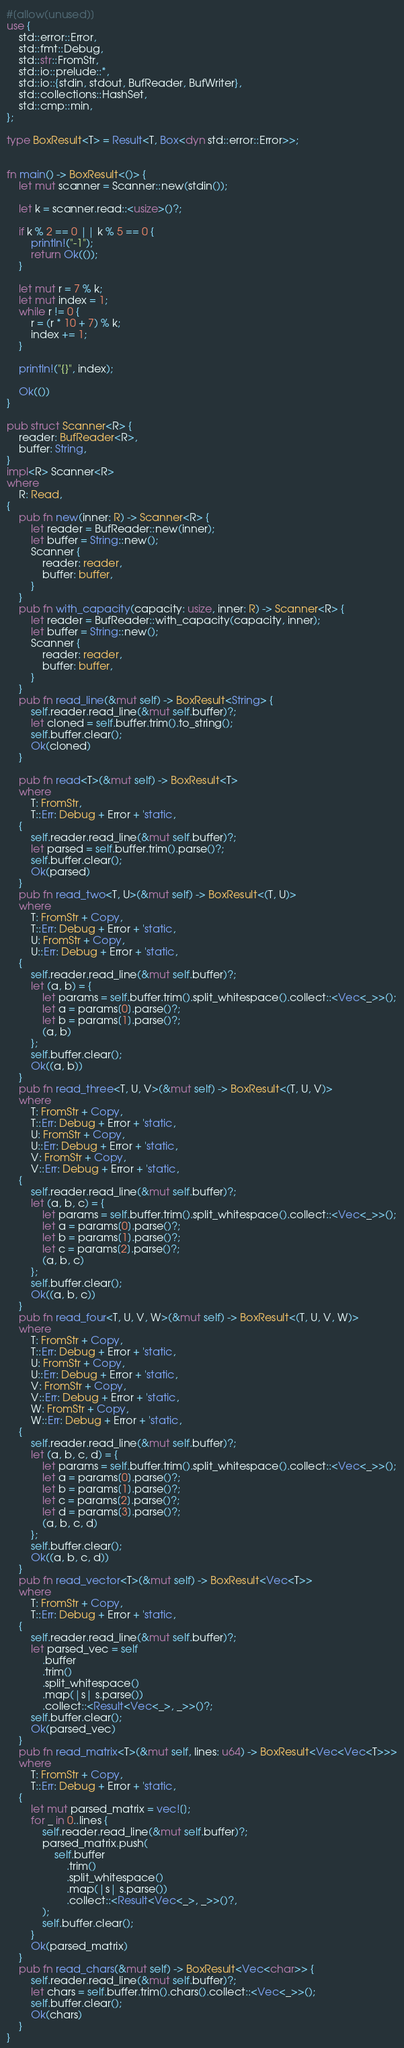Convert code to text. <code><loc_0><loc_0><loc_500><loc_500><_Rust_>#[allow(unused)]
use {
    std::error::Error,
    std::fmt::Debug,
    std::str::FromStr,
    std::io::prelude::*,
    std::io::{stdin, stdout, BufReader, BufWriter},
    std::collections::HashSet,
    std::cmp::min,
};

type BoxResult<T> = Result<T, Box<dyn std::error::Error>>;


fn main() -> BoxResult<()> {
    let mut scanner = Scanner::new(stdin());
    
    let k = scanner.read::<usize>()?;

    if k % 2 == 0 || k % 5 == 0 {
        println!("-1");
        return Ok(());
    }

    let mut r = 7 % k;
    let mut index = 1;
    while r != 0 {
        r = (r * 10 + 7) % k;
        index += 1;
    }

    println!("{}", index);

    Ok(())
}

pub struct Scanner<R> {
    reader: BufReader<R>,
    buffer: String,
}
impl<R> Scanner<R>
where
    R: Read,
{
    pub fn new(inner: R) -> Scanner<R> {
        let reader = BufReader::new(inner);
        let buffer = String::new();
        Scanner {
            reader: reader,
            buffer: buffer,
        }
    }
    pub fn with_capacity(capacity: usize, inner: R) -> Scanner<R> {
        let reader = BufReader::with_capacity(capacity, inner);
        let buffer = String::new();
        Scanner {
            reader: reader,
            buffer: buffer,
        }
    }
    pub fn read_line(&mut self) -> BoxResult<String> {
        self.reader.read_line(&mut self.buffer)?;
        let cloned = self.buffer.trim().to_string();
        self.buffer.clear();
        Ok(cloned)
    }
 
    pub fn read<T>(&mut self) -> BoxResult<T>
    where
        T: FromStr,
        T::Err: Debug + Error + 'static,
    {
        self.reader.read_line(&mut self.buffer)?;
        let parsed = self.buffer.trim().parse()?;
        self.buffer.clear();
        Ok(parsed)
    }
    pub fn read_two<T, U>(&mut self) -> BoxResult<(T, U)>
    where
        T: FromStr + Copy,
        T::Err: Debug + Error + 'static,
        U: FromStr + Copy,
        U::Err: Debug + Error + 'static,
    {
        self.reader.read_line(&mut self.buffer)?;
        let (a, b) = {
            let params = self.buffer.trim().split_whitespace().collect::<Vec<_>>();
            let a = params[0].parse()?;
            let b = params[1].parse()?;
            (a, b)
        };
        self.buffer.clear();
        Ok((a, b))
    }
    pub fn read_three<T, U, V>(&mut self) -> BoxResult<(T, U, V)>
    where
        T: FromStr + Copy,
        T::Err: Debug + Error + 'static,
        U: FromStr + Copy,
        U::Err: Debug + Error + 'static,
        V: FromStr + Copy,
        V::Err: Debug + Error + 'static,
    {
        self.reader.read_line(&mut self.buffer)?;
        let (a, b, c) = {
            let params = self.buffer.trim().split_whitespace().collect::<Vec<_>>();
            let a = params[0].parse()?;
            let b = params[1].parse()?;
            let c = params[2].parse()?;
            (a, b, c)
        };
        self.buffer.clear();
        Ok((a, b, c))
    }
    pub fn read_four<T, U, V, W>(&mut self) -> BoxResult<(T, U, V, W)>
    where
        T: FromStr + Copy,
        T::Err: Debug + Error + 'static,
        U: FromStr + Copy,
        U::Err: Debug + Error + 'static,
        V: FromStr + Copy,
        V::Err: Debug + Error + 'static,
        W: FromStr + Copy,
        W::Err: Debug + Error + 'static,
    {
        self.reader.read_line(&mut self.buffer)?;
        let (a, b, c, d) = {
            let params = self.buffer.trim().split_whitespace().collect::<Vec<_>>();
            let a = params[0].parse()?;
            let b = params[1].parse()?;
            let c = params[2].parse()?;
            let d = params[3].parse()?;
            (a, b, c, d)
        };
        self.buffer.clear();
        Ok((a, b, c, d))
    }
    pub fn read_vector<T>(&mut self) -> BoxResult<Vec<T>>
    where
        T: FromStr + Copy,
        T::Err: Debug + Error + 'static,
    {
        self.reader.read_line(&mut self.buffer)?;
        let parsed_vec = self
            .buffer
            .trim()
            .split_whitespace()
            .map(|s| s.parse())
            .collect::<Result<Vec<_>, _>>()?;
        self.buffer.clear();
        Ok(parsed_vec)
    }
    pub fn read_matrix<T>(&mut self, lines: u64) -> BoxResult<Vec<Vec<T>>>
    where
        T: FromStr + Copy,
        T::Err: Debug + Error + 'static,
    {
        let mut parsed_matrix = vec![];
        for _ in 0..lines {
            self.reader.read_line(&mut self.buffer)?;
            parsed_matrix.push(
                self.buffer
                    .trim()
                    .split_whitespace()
                    .map(|s| s.parse())
                    .collect::<Result<Vec<_>, _>>()?,
            );
            self.buffer.clear();
        }
        Ok(parsed_matrix)
    }
    pub fn read_chars(&mut self) -> BoxResult<Vec<char>> {
        self.reader.read_line(&mut self.buffer)?;
        let chars = self.buffer.trim().chars().collect::<Vec<_>>();
        self.buffer.clear();
        Ok(chars)
    }
}</code> 